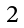<formula> <loc_0><loc_0><loc_500><loc_500>\begin{smallmatrix} { 2 } \end{smallmatrix}</formula> 